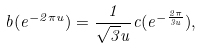Convert formula to latex. <formula><loc_0><loc_0><loc_500><loc_500>b ( e ^ { - 2 \pi u } ) = \frac { 1 } { \sqrt { 3 } u } c ( e ^ { - \frac { 2 \pi } { 3 u } } ) ,</formula> 